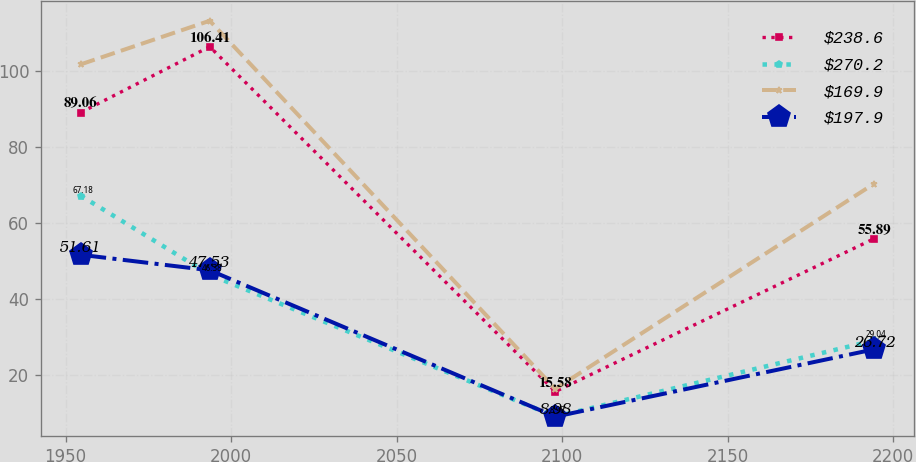Convert chart to OTSL. <chart><loc_0><loc_0><loc_500><loc_500><line_chart><ecel><fcel>$238.6<fcel>$270.2<fcel>$169.9<fcel>$197.9<nl><fcel>1954.58<fcel>89.06<fcel>67.18<fcel>101.75<fcel>51.61<nl><fcel>1993.57<fcel>106.41<fcel>46.38<fcel>113.24<fcel>47.53<nl><fcel>2097.98<fcel>15.58<fcel>8.98<fcel>16.3<fcel>8.98<nl><fcel>2194.37<fcel>55.89<fcel>29.04<fcel>70.38<fcel>26.72<nl></chart> 